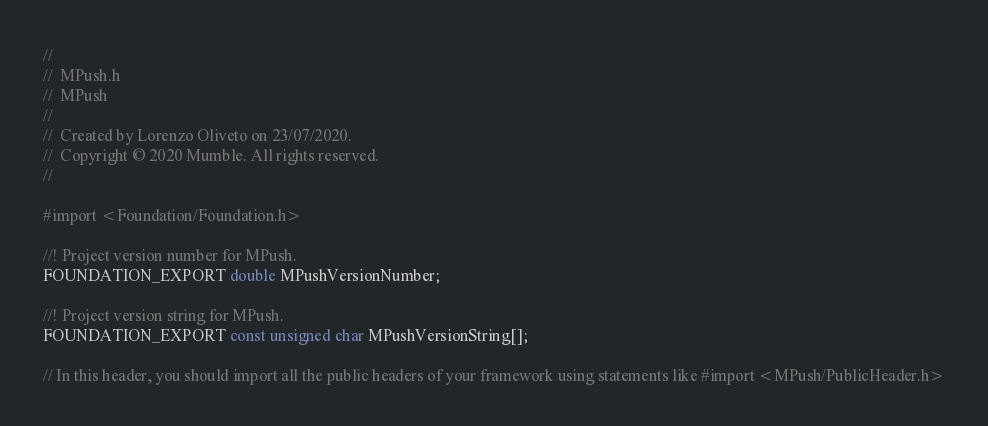Convert code to text. <code><loc_0><loc_0><loc_500><loc_500><_C_>//
//  MPush.h
//  MPush
//
//  Created by Lorenzo Oliveto on 23/07/2020.
//  Copyright © 2020 Mumble. All rights reserved.
//

#import <Foundation/Foundation.h>

//! Project version number for MPush.
FOUNDATION_EXPORT double MPushVersionNumber;

//! Project version string for MPush.
FOUNDATION_EXPORT const unsigned char MPushVersionString[];

// In this header, you should import all the public headers of your framework using statements like #import <MPush/PublicHeader.h>


</code> 